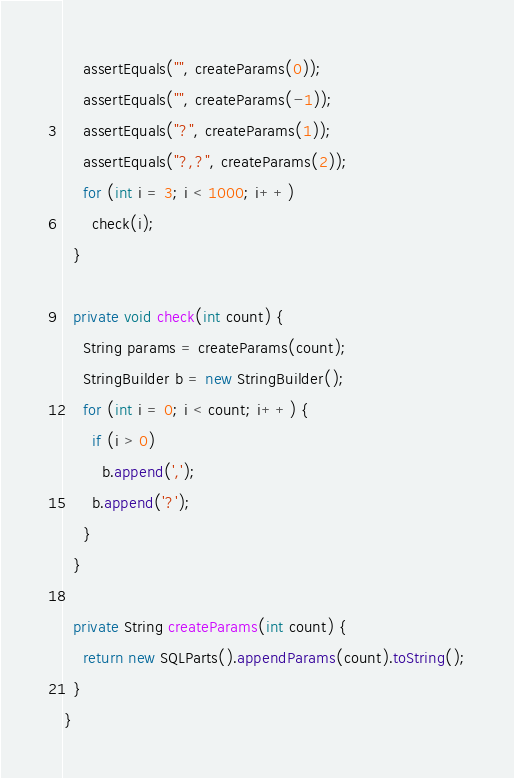<code> <loc_0><loc_0><loc_500><loc_500><_Java_>    assertEquals("", createParams(0));
    assertEquals("", createParams(-1));
    assertEquals("?", createParams(1));
    assertEquals("?,?", createParams(2));
    for (int i = 3; i < 1000; i++)
      check(i);
  }

  private void check(int count) {
    String params = createParams(count);
    StringBuilder b = new StringBuilder();
    for (int i = 0; i < count; i++) {
      if (i > 0)
        b.append(',');
      b.append('?');
    }
  }

  private String createParams(int count) {
    return new SQLParts().appendParams(count).toString();
  }
}
</code> 